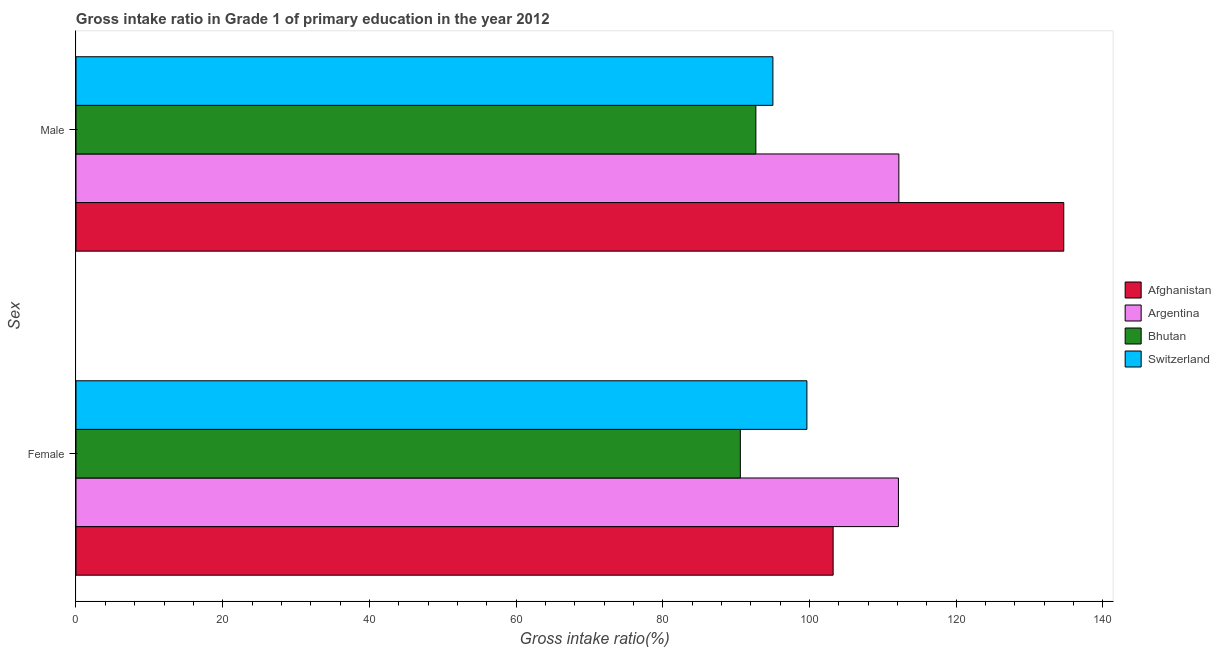How many different coloured bars are there?
Offer a terse response. 4. How many groups of bars are there?
Provide a short and direct response. 2. Are the number of bars per tick equal to the number of legend labels?
Give a very brief answer. Yes. How many bars are there on the 1st tick from the top?
Offer a terse response. 4. How many bars are there on the 1st tick from the bottom?
Make the answer very short. 4. What is the gross intake ratio(male) in Afghanistan?
Make the answer very short. 134.68. Across all countries, what is the maximum gross intake ratio(female)?
Your answer should be compact. 112.14. Across all countries, what is the minimum gross intake ratio(male)?
Ensure brevity in your answer.  92.7. In which country was the gross intake ratio(male) maximum?
Ensure brevity in your answer.  Afghanistan. In which country was the gross intake ratio(male) minimum?
Keep it short and to the point. Bhutan. What is the total gross intake ratio(female) in the graph?
Provide a short and direct response. 405.61. What is the difference between the gross intake ratio(male) in Afghanistan and that in Argentina?
Make the answer very short. 22.48. What is the difference between the gross intake ratio(male) in Switzerland and the gross intake ratio(female) in Bhutan?
Provide a short and direct response. 4.44. What is the average gross intake ratio(female) per country?
Your response must be concise. 101.4. What is the difference between the gross intake ratio(female) and gross intake ratio(male) in Afghanistan?
Offer a very short reply. -31.44. In how many countries, is the gross intake ratio(female) greater than 100 %?
Your answer should be compact. 2. What is the ratio of the gross intake ratio(male) in Bhutan to that in Afghanistan?
Offer a terse response. 0.69. Is the gross intake ratio(male) in Bhutan less than that in Argentina?
Offer a terse response. Yes. What does the 2nd bar from the top in Female represents?
Your response must be concise. Bhutan. What does the 1st bar from the bottom in Male represents?
Provide a short and direct response. Afghanistan. Are all the bars in the graph horizontal?
Provide a short and direct response. Yes. What is the difference between two consecutive major ticks on the X-axis?
Provide a short and direct response. 20. Are the values on the major ticks of X-axis written in scientific E-notation?
Your answer should be very brief. No. What is the title of the graph?
Make the answer very short. Gross intake ratio in Grade 1 of primary education in the year 2012. Does "Seychelles" appear as one of the legend labels in the graph?
Your response must be concise. No. What is the label or title of the X-axis?
Give a very brief answer. Gross intake ratio(%). What is the label or title of the Y-axis?
Your answer should be compact. Sex. What is the Gross intake ratio(%) in Afghanistan in Female?
Provide a short and direct response. 103.24. What is the Gross intake ratio(%) in Argentina in Female?
Give a very brief answer. 112.14. What is the Gross intake ratio(%) of Bhutan in Female?
Your answer should be very brief. 90.58. What is the Gross intake ratio(%) of Switzerland in Female?
Offer a terse response. 99.66. What is the Gross intake ratio(%) in Afghanistan in Male?
Give a very brief answer. 134.68. What is the Gross intake ratio(%) in Argentina in Male?
Offer a very short reply. 112.19. What is the Gross intake ratio(%) of Bhutan in Male?
Your answer should be very brief. 92.7. What is the Gross intake ratio(%) of Switzerland in Male?
Your answer should be very brief. 95.02. Across all Sex, what is the maximum Gross intake ratio(%) of Afghanistan?
Provide a succinct answer. 134.68. Across all Sex, what is the maximum Gross intake ratio(%) of Argentina?
Your answer should be very brief. 112.19. Across all Sex, what is the maximum Gross intake ratio(%) in Bhutan?
Provide a succinct answer. 92.7. Across all Sex, what is the maximum Gross intake ratio(%) of Switzerland?
Offer a very short reply. 99.66. Across all Sex, what is the minimum Gross intake ratio(%) in Afghanistan?
Your response must be concise. 103.24. Across all Sex, what is the minimum Gross intake ratio(%) in Argentina?
Make the answer very short. 112.14. Across all Sex, what is the minimum Gross intake ratio(%) in Bhutan?
Your response must be concise. 90.58. Across all Sex, what is the minimum Gross intake ratio(%) in Switzerland?
Offer a terse response. 95.02. What is the total Gross intake ratio(%) of Afghanistan in the graph?
Offer a very short reply. 237.91. What is the total Gross intake ratio(%) of Argentina in the graph?
Offer a very short reply. 224.33. What is the total Gross intake ratio(%) in Bhutan in the graph?
Provide a short and direct response. 183.28. What is the total Gross intake ratio(%) of Switzerland in the graph?
Your answer should be very brief. 194.68. What is the difference between the Gross intake ratio(%) in Afghanistan in Female and that in Male?
Your answer should be very brief. -31.44. What is the difference between the Gross intake ratio(%) of Argentina in Female and that in Male?
Offer a terse response. -0.06. What is the difference between the Gross intake ratio(%) of Bhutan in Female and that in Male?
Provide a short and direct response. -2.12. What is the difference between the Gross intake ratio(%) in Switzerland in Female and that in Male?
Provide a short and direct response. 4.64. What is the difference between the Gross intake ratio(%) in Afghanistan in Female and the Gross intake ratio(%) in Argentina in Male?
Make the answer very short. -8.96. What is the difference between the Gross intake ratio(%) of Afghanistan in Female and the Gross intake ratio(%) of Bhutan in Male?
Your response must be concise. 10.54. What is the difference between the Gross intake ratio(%) in Afghanistan in Female and the Gross intake ratio(%) in Switzerland in Male?
Offer a very short reply. 8.21. What is the difference between the Gross intake ratio(%) of Argentina in Female and the Gross intake ratio(%) of Bhutan in Male?
Ensure brevity in your answer.  19.44. What is the difference between the Gross intake ratio(%) in Argentina in Female and the Gross intake ratio(%) in Switzerland in Male?
Provide a succinct answer. 17.12. What is the difference between the Gross intake ratio(%) of Bhutan in Female and the Gross intake ratio(%) of Switzerland in Male?
Your answer should be very brief. -4.44. What is the average Gross intake ratio(%) in Afghanistan per Sex?
Provide a short and direct response. 118.96. What is the average Gross intake ratio(%) in Argentina per Sex?
Offer a very short reply. 112.17. What is the average Gross intake ratio(%) of Bhutan per Sex?
Your answer should be very brief. 91.64. What is the average Gross intake ratio(%) of Switzerland per Sex?
Your answer should be compact. 97.34. What is the difference between the Gross intake ratio(%) of Afghanistan and Gross intake ratio(%) of Argentina in Female?
Provide a short and direct response. -8.9. What is the difference between the Gross intake ratio(%) in Afghanistan and Gross intake ratio(%) in Bhutan in Female?
Provide a short and direct response. 12.65. What is the difference between the Gross intake ratio(%) of Afghanistan and Gross intake ratio(%) of Switzerland in Female?
Ensure brevity in your answer.  3.58. What is the difference between the Gross intake ratio(%) in Argentina and Gross intake ratio(%) in Bhutan in Female?
Offer a very short reply. 21.56. What is the difference between the Gross intake ratio(%) in Argentina and Gross intake ratio(%) in Switzerland in Female?
Your answer should be very brief. 12.48. What is the difference between the Gross intake ratio(%) in Bhutan and Gross intake ratio(%) in Switzerland in Female?
Ensure brevity in your answer.  -9.08. What is the difference between the Gross intake ratio(%) of Afghanistan and Gross intake ratio(%) of Argentina in Male?
Offer a terse response. 22.48. What is the difference between the Gross intake ratio(%) in Afghanistan and Gross intake ratio(%) in Bhutan in Male?
Ensure brevity in your answer.  41.98. What is the difference between the Gross intake ratio(%) in Afghanistan and Gross intake ratio(%) in Switzerland in Male?
Your answer should be very brief. 39.66. What is the difference between the Gross intake ratio(%) of Argentina and Gross intake ratio(%) of Bhutan in Male?
Make the answer very short. 19.5. What is the difference between the Gross intake ratio(%) in Argentina and Gross intake ratio(%) in Switzerland in Male?
Your answer should be compact. 17.17. What is the difference between the Gross intake ratio(%) of Bhutan and Gross intake ratio(%) of Switzerland in Male?
Give a very brief answer. -2.32. What is the ratio of the Gross intake ratio(%) in Afghanistan in Female to that in Male?
Ensure brevity in your answer.  0.77. What is the ratio of the Gross intake ratio(%) of Bhutan in Female to that in Male?
Make the answer very short. 0.98. What is the ratio of the Gross intake ratio(%) of Switzerland in Female to that in Male?
Your answer should be very brief. 1.05. What is the difference between the highest and the second highest Gross intake ratio(%) in Afghanistan?
Offer a very short reply. 31.44. What is the difference between the highest and the second highest Gross intake ratio(%) in Argentina?
Provide a short and direct response. 0.06. What is the difference between the highest and the second highest Gross intake ratio(%) in Bhutan?
Provide a short and direct response. 2.12. What is the difference between the highest and the second highest Gross intake ratio(%) of Switzerland?
Make the answer very short. 4.64. What is the difference between the highest and the lowest Gross intake ratio(%) of Afghanistan?
Offer a very short reply. 31.44. What is the difference between the highest and the lowest Gross intake ratio(%) of Argentina?
Provide a succinct answer. 0.06. What is the difference between the highest and the lowest Gross intake ratio(%) of Bhutan?
Ensure brevity in your answer.  2.12. What is the difference between the highest and the lowest Gross intake ratio(%) in Switzerland?
Ensure brevity in your answer.  4.64. 